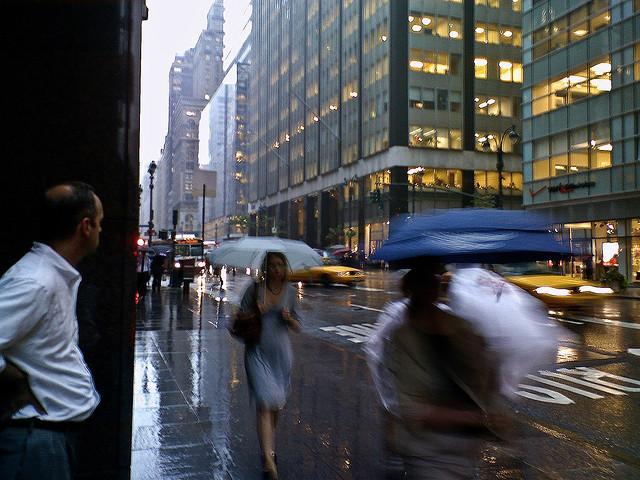What is the man wearing white shirt waiting for?

Choices:
A) rain stopping
B) crossing street
C) his kid
D) bus rain stopping 